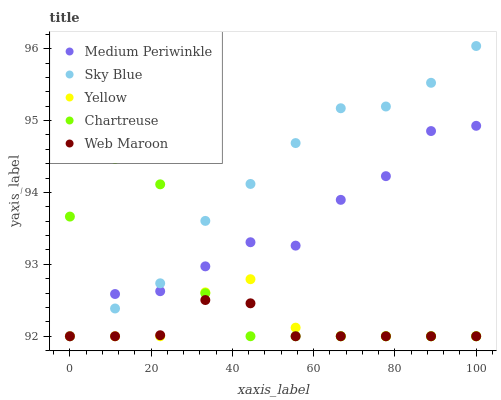Does Web Maroon have the minimum area under the curve?
Answer yes or no. Yes. Does Sky Blue have the maximum area under the curve?
Answer yes or no. Yes. Does Chartreuse have the minimum area under the curve?
Answer yes or no. No. Does Chartreuse have the maximum area under the curve?
Answer yes or no. No. Is Web Maroon the smoothest?
Answer yes or no. Yes. Is Chartreuse the roughest?
Answer yes or no. Yes. Is Sky Blue the smoothest?
Answer yes or no. No. Is Sky Blue the roughest?
Answer yes or no. No. Does Web Maroon have the lowest value?
Answer yes or no. Yes. Does Sky Blue have the highest value?
Answer yes or no. Yes. Does Chartreuse have the highest value?
Answer yes or no. No. Does Chartreuse intersect Medium Periwinkle?
Answer yes or no. Yes. Is Chartreuse less than Medium Periwinkle?
Answer yes or no. No. Is Chartreuse greater than Medium Periwinkle?
Answer yes or no. No. 